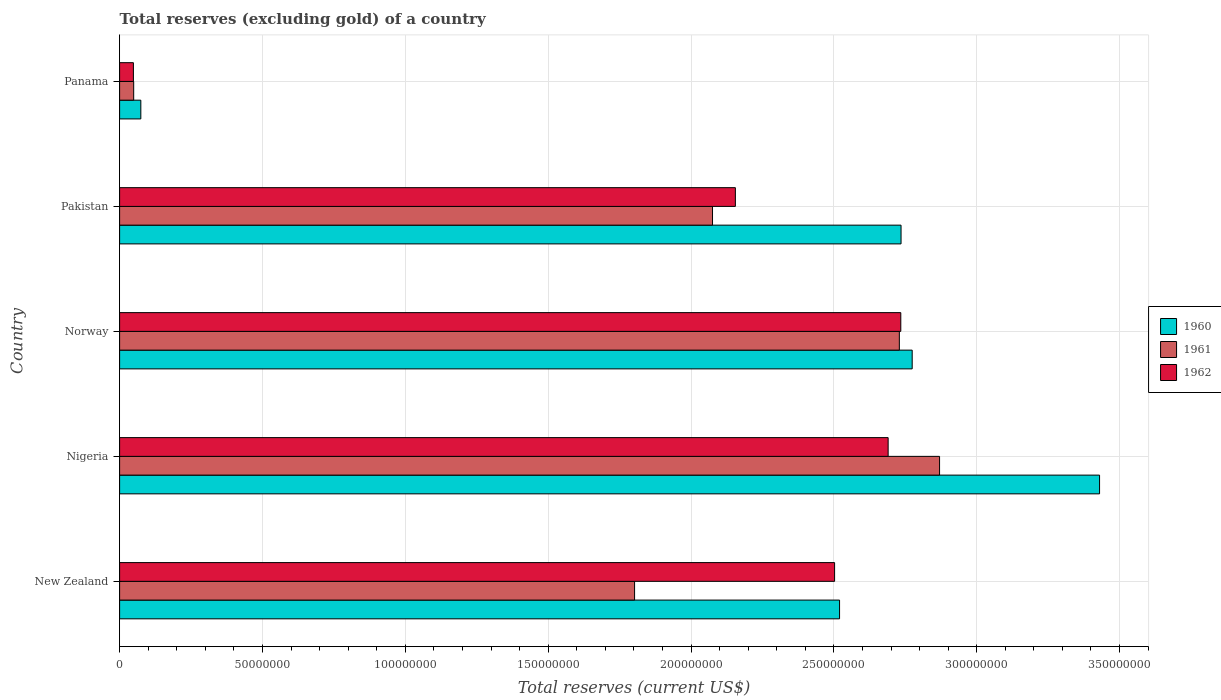Are the number of bars on each tick of the Y-axis equal?
Provide a short and direct response. Yes. What is the label of the 5th group of bars from the top?
Provide a short and direct response. New Zealand. What is the total reserves (excluding gold) in 1960 in Pakistan?
Give a very brief answer. 2.74e+08. Across all countries, what is the maximum total reserves (excluding gold) in 1961?
Offer a terse response. 2.87e+08. Across all countries, what is the minimum total reserves (excluding gold) in 1960?
Give a very brief answer. 7.43e+06. In which country was the total reserves (excluding gold) in 1960 maximum?
Provide a short and direct response. Nigeria. In which country was the total reserves (excluding gold) in 1960 minimum?
Give a very brief answer. Panama. What is the total total reserves (excluding gold) in 1960 in the graph?
Provide a short and direct response. 1.15e+09. What is the difference between the total reserves (excluding gold) in 1961 in Nigeria and that in Pakistan?
Offer a terse response. 7.95e+07. What is the difference between the total reserves (excluding gold) in 1960 in Panama and the total reserves (excluding gold) in 1961 in Pakistan?
Offer a very short reply. -2.00e+08. What is the average total reserves (excluding gold) in 1962 per country?
Your response must be concise. 2.03e+08. What is the difference between the total reserves (excluding gold) in 1960 and total reserves (excluding gold) in 1961 in Norway?
Your answer should be very brief. 4.50e+06. In how many countries, is the total reserves (excluding gold) in 1962 greater than 290000000 US$?
Offer a terse response. 0. What is the ratio of the total reserves (excluding gold) in 1962 in Pakistan to that in Panama?
Offer a very short reply. 44.62. Is the difference between the total reserves (excluding gold) in 1960 in New Zealand and Norway greater than the difference between the total reserves (excluding gold) in 1961 in New Zealand and Norway?
Your response must be concise. Yes. What is the difference between the highest and the second highest total reserves (excluding gold) in 1961?
Give a very brief answer. 1.41e+07. What is the difference between the highest and the lowest total reserves (excluding gold) in 1961?
Provide a short and direct response. 2.82e+08. In how many countries, is the total reserves (excluding gold) in 1962 greater than the average total reserves (excluding gold) in 1962 taken over all countries?
Keep it short and to the point. 4. What does the 2nd bar from the top in Panama represents?
Your response must be concise. 1961. Is it the case that in every country, the sum of the total reserves (excluding gold) in 1961 and total reserves (excluding gold) in 1960 is greater than the total reserves (excluding gold) in 1962?
Keep it short and to the point. Yes. Are all the bars in the graph horizontal?
Keep it short and to the point. Yes. How many countries are there in the graph?
Give a very brief answer. 5. Are the values on the major ticks of X-axis written in scientific E-notation?
Make the answer very short. No. Does the graph contain any zero values?
Make the answer very short. No. Where does the legend appear in the graph?
Provide a succinct answer. Center right. What is the title of the graph?
Provide a short and direct response. Total reserves (excluding gold) of a country. What is the label or title of the X-axis?
Ensure brevity in your answer.  Total reserves (current US$). What is the label or title of the Y-axis?
Your answer should be compact. Country. What is the Total reserves (current US$) in 1960 in New Zealand?
Provide a short and direct response. 2.52e+08. What is the Total reserves (current US$) in 1961 in New Zealand?
Offer a terse response. 1.80e+08. What is the Total reserves (current US$) of 1962 in New Zealand?
Offer a terse response. 2.50e+08. What is the Total reserves (current US$) in 1960 in Nigeria?
Provide a succinct answer. 3.43e+08. What is the Total reserves (current US$) in 1961 in Nigeria?
Offer a very short reply. 2.87e+08. What is the Total reserves (current US$) of 1962 in Nigeria?
Give a very brief answer. 2.69e+08. What is the Total reserves (current US$) in 1960 in Norway?
Provide a succinct answer. 2.77e+08. What is the Total reserves (current US$) of 1961 in Norway?
Offer a very short reply. 2.73e+08. What is the Total reserves (current US$) of 1962 in Norway?
Give a very brief answer. 2.73e+08. What is the Total reserves (current US$) of 1960 in Pakistan?
Your answer should be very brief. 2.74e+08. What is the Total reserves (current US$) in 1961 in Pakistan?
Keep it short and to the point. 2.08e+08. What is the Total reserves (current US$) of 1962 in Pakistan?
Keep it short and to the point. 2.16e+08. What is the Total reserves (current US$) in 1960 in Panama?
Provide a succinct answer. 7.43e+06. What is the Total reserves (current US$) of 1961 in Panama?
Give a very brief answer. 4.93e+06. What is the Total reserves (current US$) of 1962 in Panama?
Provide a succinct answer. 4.83e+06. Across all countries, what is the maximum Total reserves (current US$) of 1960?
Make the answer very short. 3.43e+08. Across all countries, what is the maximum Total reserves (current US$) in 1961?
Your answer should be very brief. 2.87e+08. Across all countries, what is the maximum Total reserves (current US$) in 1962?
Ensure brevity in your answer.  2.73e+08. Across all countries, what is the minimum Total reserves (current US$) in 1960?
Your response must be concise. 7.43e+06. Across all countries, what is the minimum Total reserves (current US$) of 1961?
Give a very brief answer. 4.93e+06. Across all countries, what is the minimum Total reserves (current US$) of 1962?
Offer a very short reply. 4.83e+06. What is the total Total reserves (current US$) in 1960 in the graph?
Your answer should be compact. 1.15e+09. What is the total Total reserves (current US$) of 1961 in the graph?
Give a very brief answer. 9.53e+08. What is the total Total reserves (current US$) of 1962 in the graph?
Make the answer very short. 1.01e+09. What is the difference between the Total reserves (current US$) in 1960 in New Zealand and that in Nigeria?
Provide a succinct answer. -9.10e+07. What is the difference between the Total reserves (current US$) of 1961 in New Zealand and that in Nigeria?
Keep it short and to the point. -1.07e+08. What is the difference between the Total reserves (current US$) of 1962 in New Zealand and that in Nigeria?
Keep it short and to the point. -1.87e+07. What is the difference between the Total reserves (current US$) in 1960 in New Zealand and that in Norway?
Keep it short and to the point. -2.54e+07. What is the difference between the Total reserves (current US$) of 1961 in New Zealand and that in Norway?
Provide a short and direct response. -9.27e+07. What is the difference between the Total reserves (current US$) of 1962 in New Zealand and that in Norway?
Your answer should be compact. -2.32e+07. What is the difference between the Total reserves (current US$) in 1960 in New Zealand and that in Pakistan?
Offer a terse response. -2.15e+07. What is the difference between the Total reserves (current US$) of 1961 in New Zealand and that in Pakistan?
Your response must be concise. -2.73e+07. What is the difference between the Total reserves (current US$) of 1962 in New Zealand and that in Pakistan?
Ensure brevity in your answer.  3.47e+07. What is the difference between the Total reserves (current US$) of 1960 in New Zealand and that in Panama?
Your response must be concise. 2.45e+08. What is the difference between the Total reserves (current US$) of 1961 in New Zealand and that in Panama?
Provide a succinct answer. 1.75e+08. What is the difference between the Total reserves (current US$) of 1962 in New Zealand and that in Panama?
Provide a succinct answer. 2.45e+08. What is the difference between the Total reserves (current US$) of 1960 in Nigeria and that in Norway?
Offer a terse response. 6.56e+07. What is the difference between the Total reserves (current US$) in 1961 in Nigeria and that in Norway?
Provide a succinct answer. 1.41e+07. What is the difference between the Total reserves (current US$) of 1962 in Nigeria and that in Norway?
Provide a short and direct response. -4.43e+06. What is the difference between the Total reserves (current US$) in 1960 in Nigeria and that in Pakistan?
Give a very brief answer. 6.95e+07. What is the difference between the Total reserves (current US$) of 1961 in Nigeria and that in Pakistan?
Offer a very short reply. 7.95e+07. What is the difference between the Total reserves (current US$) in 1962 in Nigeria and that in Pakistan?
Offer a very short reply. 5.35e+07. What is the difference between the Total reserves (current US$) in 1960 in Nigeria and that in Panama?
Offer a terse response. 3.36e+08. What is the difference between the Total reserves (current US$) of 1961 in Nigeria and that in Panama?
Your response must be concise. 2.82e+08. What is the difference between the Total reserves (current US$) in 1962 in Nigeria and that in Panama?
Your answer should be compact. 2.64e+08. What is the difference between the Total reserves (current US$) of 1960 in Norway and that in Pakistan?
Make the answer very short. 3.90e+06. What is the difference between the Total reserves (current US$) in 1961 in Norway and that in Pakistan?
Offer a very short reply. 6.54e+07. What is the difference between the Total reserves (current US$) of 1962 in Norway and that in Pakistan?
Make the answer very short. 5.79e+07. What is the difference between the Total reserves (current US$) of 1960 in Norway and that in Panama?
Give a very brief answer. 2.70e+08. What is the difference between the Total reserves (current US$) in 1961 in Norway and that in Panama?
Give a very brief answer. 2.68e+08. What is the difference between the Total reserves (current US$) in 1962 in Norway and that in Panama?
Keep it short and to the point. 2.69e+08. What is the difference between the Total reserves (current US$) in 1960 in Pakistan and that in Panama?
Make the answer very short. 2.66e+08. What is the difference between the Total reserves (current US$) of 1961 in Pakistan and that in Panama?
Offer a terse response. 2.03e+08. What is the difference between the Total reserves (current US$) in 1962 in Pakistan and that in Panama?
Make the answer very short. 2.11e+08. What is the difference between the Total reserves (current US$) of 1960 in New Zealand and the Total reserves (current US$) of 1961 in Nigeria?
Your answer should be very brief. -3.50e+07. What is the difference between the Total reserves (current US$) in 1960 in New Zealand and the Total reserves (current US$) in 1962 in Nigeria?
Your answer should be compact. -1.70e+07. What is the difference between the Total reserves (current US$) of 1961 in New Zealand and the Total reserves (current US$) of 1962 in Nigeria?
Offer a terse response. -8.88e+07. What is the difference between the Total reserves (current US$) in 1960 in New Zealand and the Total reserves (current US$) in 1961 in Norway?
Ensure brevity in your answer.  -2.09e+07. What is the difference between the Total reserves (current US$) of 1960 in New Zealand and the Total reserves (current US$) of 1962 in Norway?
Your answer should be compact. -2.14e+07. What is the difference between the Total reserves (current US$) in 1961 in New Zealand and the Total reserves (current US$) in 1962 in Norway?
Give a very brief answer. -9.32e+07. What is the difference between the Total reserves (current US$) of 1960 in New Zealand and the Total reserves (current US$) of 1961 in Pakistan?
Offer a very short reply. 4.45e+07. What is the difference between the Total reserves (current US$) of 1960 in New Zealand and the Total reserves (current US$) of 1962 in Pakistan?
Your response must be concise. 3.65e+07. What is the difference between the Total reserves (current US$) in 1961 in New Zealand and the Total reserves (current US$) in 1962 in Pakistan?
Your response must be concise. -3.53e+07. What is the difference between the Total reserves (current US$) of 1960 in New Zealand and the Total reserves (current US$) of 1961 in Panama?
Provide a succinct answer. 2.47e+08. What is the difference between the Total reserves (current US$) of 1960 in New Zealand and the Total reserves (current US$) of 1962 in Panama?
Provide a succinct answer. 2.47e+08. What is the difference between the Total reserves (current US$) of 1961 in New Zealand and the Total reserves (current US$) of 1962 in Panama?
Your answer should be very brief. 1.75e+08. What is the difference between the Total reserves (current US$) in 1960 in Nigeria and the Total reserves (current US$) in 1961 in Norway?
Offer a terse response. 7.01e+07. What is the difference between the Total reserves (current US$) in 1960 in Nigeria and the Total reserves (current US$) in 1962 in Norway?
Give a very brief answer. 6.96e+07. What is the difference between the Total reserves (current US$) of 1961 in Nigeria and the Total reserves (current US$) of 1962 in Norway?
Give a very brief answer. 1.36e+07. What is the difference between the Total reserves (current US$) of 1960 in Nigeria and the Total reserves (current US$) of 1961 in Pakistan?
Provide a short and direct response. 1.35e+08. What is the difference between the Total reserves (current US$) of 1960 in Nigeria and the Total reserves (current US$) of 1962 in Pakistan?
Make the answer very short. 1.27e+08. What is the difference between the Total reserves (current US$) of 1961 in Nigeria and the Total reserves (current US$) of 1962 in Pakistan?
Your answer should be very brief. 7.15e+07. What is the difference between the Total reserves (current US$) in 1960 in Nigeria and the Total reserves (current US$) in 1961 in Panama?
Make the answer very short. 3.38e+08. What is the difference between the Total reserves (current US$) of 1960 in Nigeria and the Total reserves (current US$) of 1962 in Panama?
Your answer should be compact. 3.38e+08. What is the difference between the Total reserves (current US$) in 1961 in Nigeria and the Total reserves (current US$) in 1962 in Panama?
Your answer should be compact. 2.82e+08. What is the difference between the Total reserves (current US$) of 1960 in Norway and the Total reserves (current US$) of 1961 in Pakistan?
Provide a succinct answer. 6.99e+07. What is the difference between the Total reserves (current US$) in 1960 in Norway and the Total reserves (current US$) in 1962 in Pakistan?
Offer a very short reply. 6.19e+07. What is the difference between the Total reserves (current US$) of 1961 in Norway and the Total reserves (current US$) of 1962 in Pakistan?
Provide a succinct answer. 5.74e+07. What is the difference between the Total reserves (current US$) of 1960 in Norway and the Total reserves (current US$) of 1961 in Panama?
Offer a very short reply. 2.72e+08. What is the difference between the Total reserves (current US$) of 1960 in Norway and the Total reserves (current US$) of 1962 in Panama?
Keep it short and to the point. 2.73e+08. What is the difference between the Total reserves (current US$) of 1961 in Norway and the Total reserves (current US$) of 1962 in Panama?
Provide a short and direct response. 2.68e+08. What is the difference between the Total reserves (current US$) of 1960 in Pakistan and the Total reserves (current US$) of 1961 in Panama?
Keep it short and to the point. 2.69e+08. What is the difference between the Total reserves (current US$) of 1960 in Pakistan and the Total reserves (current US$) of 1962 in Panama?
Offer a very short reply. 2.69e+08. What is the difference between the Total reserves (current US$) in 1961 in Pakistan and the Total reserves (current US$) in 1962 in Panama?
Provide a short and direct response. 2.03e+08. What is the average Total reserves (current US$) in 1960 per country?
Give a very brief answer. 2.31e+08. What is the average Total reserves (current US$) of 1961 per country?
Provide a short and direct response. 1.91e+08. What is the average Total reserves (current US$) in 1962 per country?
Your response must be concise. 2.03e+08. What is the difference between the Total reserves (current US$) of 1960 and Total reserves (current US$) of 1961 in New Zealand?
Your response must be concise. 7.18e+07. What is the difference between the Total reserves (current US$) in 1960 and Total reserves (current US$) in 1962 in New Zealand?
Your answer should be very brief. 1.74e+06. What is the difference between the Total reserves (current US$) of 1961 and Total reserves (current US$) of 1962 in New Zealand?
Ensure brevity in your answer.  -7.00e+07. What is the difference between the Total reserves (current US$) of 1960 and Total reserves (current US$) of 1961 in Nigeria?
Your response must be concise. 5.60e+07. What is the difference between the Total reserves (current US$) in 1960 and Total reserves (current US$) in 1962 in Nigeria?
Provide a succinct answer. 7.40e+07. What is the difference between the Total reserves (current US$) of 1961 and Total reserves (current US$) of 1962 in Nigeria?
Offer a very short reply. 1.80e+07. What is the difference between the Total reserves (current US$) in 1960 and Total reserves (current US$) in 1961 in Norway?
Ensure brevity in your answer.  4.50e+06. What is the difference between the Total reserves (current US$) of 1960 and Total reserves (current US$) of 1962 in Norway?
Provide a short and direct response. 3.99e+06. What is the difference between the Total reserves (current US$) of 1961 and Total reserves (current US$) of 1962 in Norway?
Your answer should be compact. -5.10e+05. What is the difference between the Total reserves (current US$) in 1960 and Total reserves (current US$) in 1961 in Pakistan?
Your answer should be compact. 6.60e+07. What is the difference between the Total reserves (current US$) of 1960 and Total reserves (current US$) of 1962 in Pakistan?
Provide a succinct answer. 5.80e+07. What is the difference between the Total reserves (current US$) in 1961 and Total reserves (current US$) in 1962 in Pakistan?
Give a very brief answer. -8.00e+06. What is the difference between the Total reserves (current US$) in 1960 and Total reserves (current US$) in 1961 in Panama?
Give a very brief answer. 2.50e+06. What is the difference between the Total reserves (current US$) in 1960 and Total reserves (current US$) in 1962 in Panama?
Give a very brief answer. 2.60e+06. What is the difference between the Total reserves (current US$) of 1961 and Total reserves (current US$) of 1962 in Panama?
Keep it short and to the point. 1.00e+05. What is the ratio of the Total reserves (current US$) in 1960 in New Zealand to that in Nigeria?
Provide a succinct answer. 0.73. What is the ratio of the Total reserves (current US$) in 1961 in New Zealand to that in Nigeria?
Offer a very short reply. 0.63. What is the ratio of the Total reserves (current US$) in 1962 in New Zealand to that in Nigeria?
Offer a terse response. 0.93. What is the ratio of the Total reserves (current US$) in 1960 in New Zealand to that in Norway?
Offer a very short reply. 0.91. What is the ratio of the Total reserves (current US$) in 1961 in New Zealand to that in Norway?
Make the answer very short. 0.66. What is the ratio of the Total reserves (current US$) of 1962 in New Zealand to that in Norway?
Offer a terse response. 0.92. What is the ratio of the Total reserves (current US$) of 1960 in New Zealand to that in Pakistan?
Offer a very short reply. 0.92. What is the ratio of the Total reserves (current US$) in 1961 in New Zealand to that in Pakistan?
Keep it short and to the point. 0.87. What is the ratio of the Total reserves (current US$) of 1962 in New Zealand to that in Pakistan?
Make the answer very short. 1.16. What is the ratio of the Total reserves (current US$) in 1960 in New Zealand to that in Panama?
Provide a succinct answer. 33.92. What is the ratio of the Total reserves (current US$) of 1961 in New Zealand to that in Panama?
Keep it short and to the point. 36.56. What is the ratio of the Total reserves (current US$) in 1962 in New Zealand to that in Panama?
Ensure brevity in your answer.  51.81. What is the ratio of the Total reserves (current US$) of 1960 in Nigeria to that in Norway?
Provide a succinct answer. 1.24. What is the ratio of the Total reserves (current US$) of 1961 in Nigeria to that in Norway?
Offer a terse response. 1.05. What is the ratio of the Total reserves (current US$) of 1962 in Nigeria to that in Norway?
Your response must be concise. 0.98. What is the ratio of the Total reserves (current US$) in 1960 in Nigeria to that in Pakistan?
Your answer should be compact. 1.25. What is the ratio of the Total reserves (current US$) of 1961 in Nigeria to that in Pakistan?
Your answer should be very brief. 1.38. What is the ratio of the Total reserves (current US$) of 1962 in Nigeria to that in Pakistan?
Offer a terse response. 1.25. What is the ratio of the Total reserves (current US$) in 1960 in Nigeria to that in Panama?
Provide a short and direct response. 46.16. What is the ratio of the Total reserves (current US$) in 1961 in Nigeria to that in Panama?
Offer a terse response. 58.22. What is the ratio of the Total reserves (current US$) in 1962 in Nigeria to that in Panama?
Make the answer very short. 55.69. What is the ratio of the Total reserves (current US$) in 1960 in Norway to that in Pakistan?
Make the answer very short. 1.01. What is the ratio of the Total reserves (current US$) in 1961 in Norway to that in Pakistan?
Provide a short and direct response. 1.32. What is the ratio of the Total reserves (current US$) in 1962 in Norway to that in Pakistan?
Ensure brevity in your answer.  1.27. What is the ratio of the Total reserves (current US$) of 1960 in Norway to that in Panama?
Provide a succinct answer. 37.34. What is the ratio of the Total reserves (current US$) in 1961 in Norway to that in Panama?
Ensure brevity in your answer.  55.36. What is the ratio of the Total reserves (current US$) in 1962 in Norway to that in Panama?
Offer a terse response. 56.61. What is the ratio of the Total reserves (current US$) of 1960 in Pakistan to that in Panama?
Offer a very short reply. 36.81. What is the ratio of the Total reserves (current US$) in 1961 in Pakistan to that in Panama?
Make the answer very short. 42.1. What is the ratio of the Total reserves (current US$) in 1962 in Pakistan to that in Panama?
Your response must be concise. 44.62. What is the difference between the highest and the second highest Total reserves (current US$) in 1960?
Provide a succinct answer. 6.56e+07. What is the difference between the highest and the second highest Total reserves (current US$) in 1961?
Keep it short and to the point. 1.41e+07. What is the difference between the highest and the second highest Total reserves (current US$) in 1962?
Ensure brevity in your answer.  4.43e+06. What is the difference between the highest and the lowest Total reserves (current US$) in 1960?
Your response must be concise. 3.36e+08. What is the difference between the highest and the lowest Total reserves (current US$) of 1961?
Give a very brief answer. 2.82e+08. What is the difference between the highest and the lowest Total reserves (current US$) in 1962?
Offer a very short reply. 2.69e+08. 